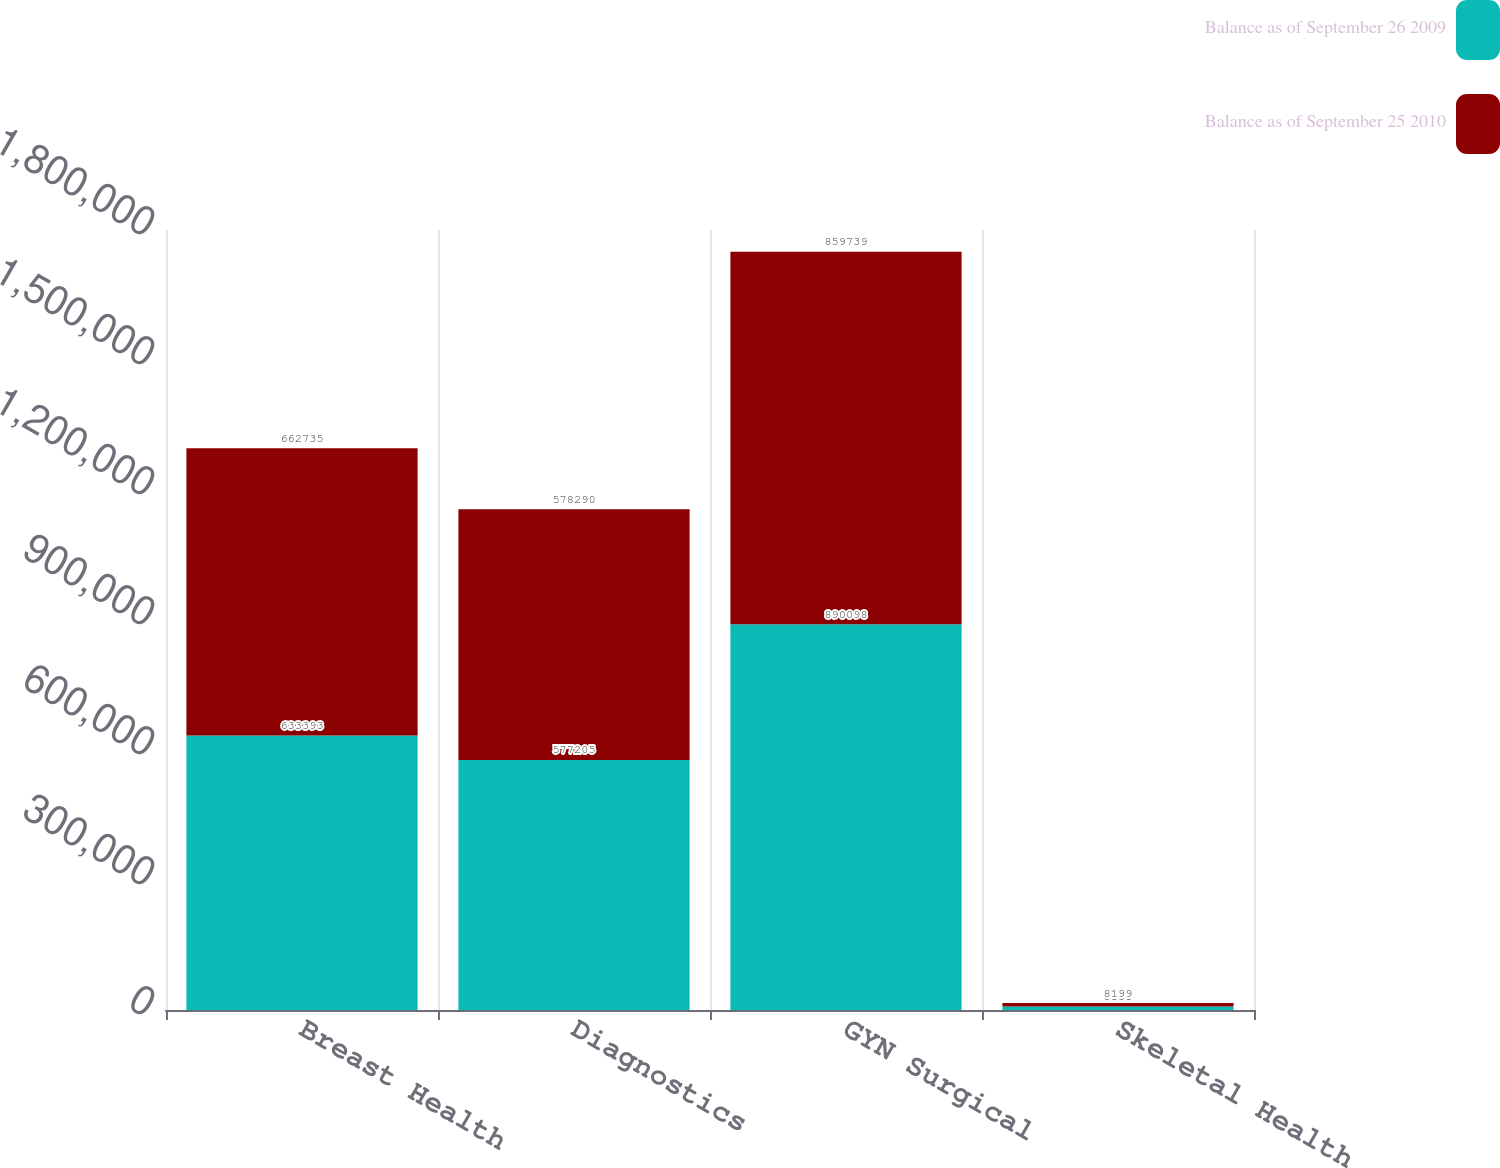Convert chart. <chart><loc_0><loc_0><loc_500><loc_500><stacked_bar_chart><ecel><fcel>Breast Health<fcel>Diagnostics<fcel>GYN Surgical<fcel>Skeletal Health<nl><fcel>Balance as of September 26 2009<fcel>633393<fcel>577205<fcel>890098<fcel>8151<nl><fcel>Balance as of September 25 2010<fcel>662735<fcel>578290<fcel>859739<fcel>8199<nl></chart> 